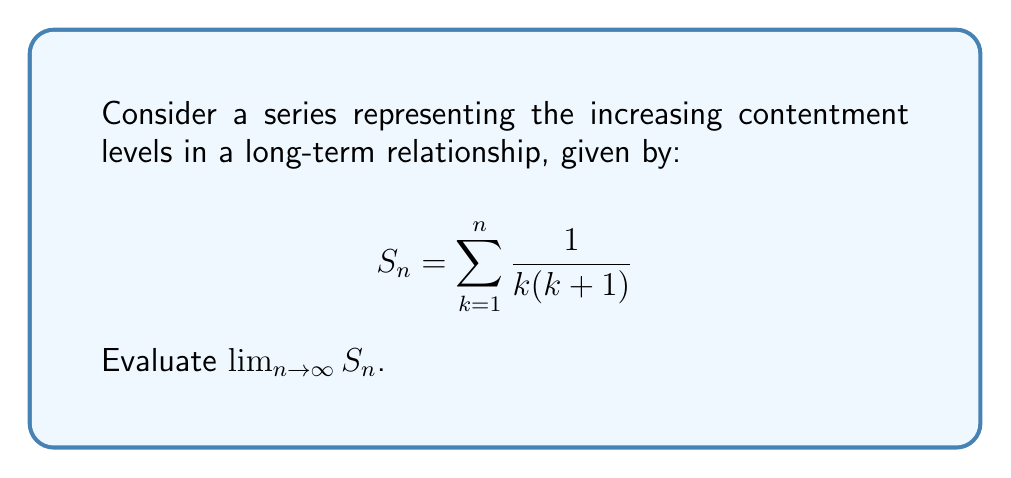Give your solution to this math problem. Let's approach this step-by-step:

1) First, let's recognize the general term of the series:
   $$a_k = \frac{1}{k(k+1)}$$

2) We can use partial fraction decomposition to simplify this:
   $$\frac{1}{k(k+1)} = \frac{1}{k} - \frac{1}{k+1}$$

3) Now, we can rewrite our series:
   $$S_n = \sum_{k=1}^n (\frac{1}{k} - \frac{1}{k+1})$$

4) This is a telescoping series. Let's expand it:
   $$S_n = (1 - \frac{1}{2}) + (\frac{1}{2} - \frac{1}{3}) + (\frac{1}{3} - \frac{1}{4}) + ... + (\frac{1}{n} - \frac{1}{n+1})$$

5) Notice how all terms except the first and last cancel out:
   $$S_n = 1 - \frac{1}{n+1}$$

6) Now, we can evaluate the limit:
   $$\lim_{n \to \infty} S_n = \lim_{n \to \infty} (1 - \frac{1}{n+1}) = 1 - \lim_{n \to \infty} \frac{1}{n+1} = 1 - 0 = 1$$

This result suggests that as the relationship progresses (n increases), the contentment level approaches 1, representing complete contentment.
Answer: $1$ 